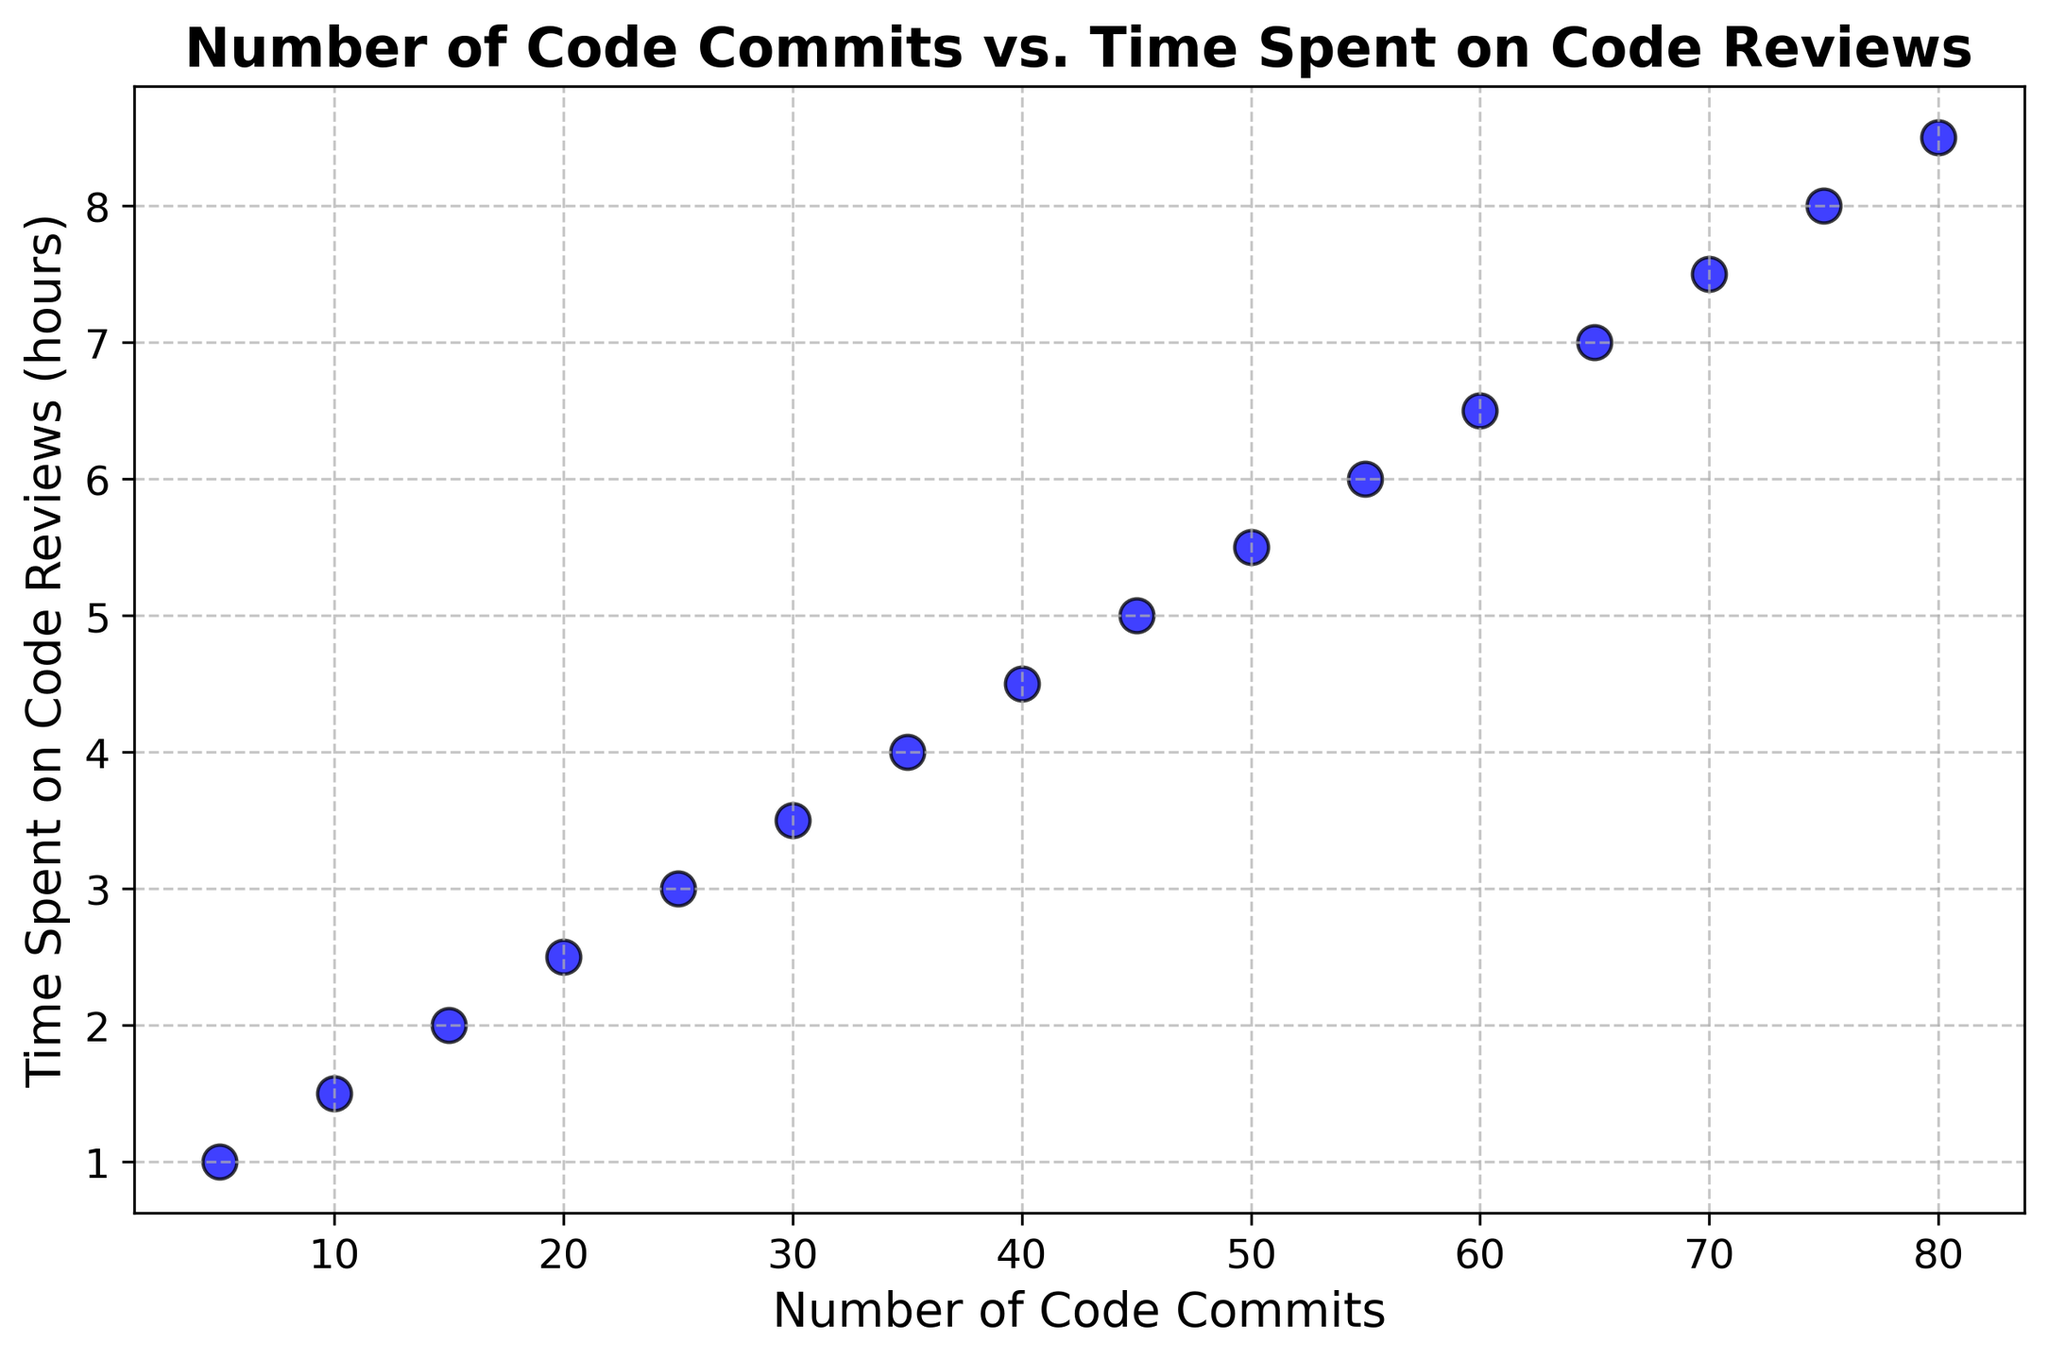Which data point shows the highest number of code commits? The scatter plot shows the number of code commits on the x-axis. The point farthest to the right represents the highest number of code commits, which is 80.
Answer: 80 Which data point shows the least amount of time spent on code reviews? The scatter plot shows the time spent on code reviews on the y-axis. The point lowest on the y-axis represents the least time spent on code reviews, which is 1 hour.
Answer: 1 hour Is there a visible trend or relationship between the number of code commits and time spent on code reviews? Observing the scatter plot, as the number of code commits increases, the time spent on code reviews also increases in a linear fashion. This indicates a positive linear relationship between the two variables.
Answer: Yes, positive linear relationship What is the time spent on code reviews when there are 45 code commits? Locate the data point for 45 code commits on the x-axis. Following it up to the corresponding point on the y-axis, we see that it corresponds to 5 hours of code reviews.
Answer: 5 hours Which has more commits: the data point with 4.5 hours of reviews or the data point with 7.5 hours of reviews? The data points for 4.5 hours and 7.5 hours of reviews fall at 40 commits and 70 commits, respectively. Therefore, 70 commits have more.
Answer: 70 commits What is the average time spent on code reviews for the data points with exactly 25 to 55 code commits? Identify the data points within the range 25 to 55 commits (25, 30, 35, 40, 45, 50, 55). The corresponding review times are 3, 3.5, 4, 4.5, 5, 5.5, 6 hours. Calculate the average: (3+3.5+4+4.5+5+5.5+6)/7 = 31.5/7 = 4.5 hours.
Answer: 4.5 hours What is the difference in time spent on code reviews between 60 commits and 20 commits? The data point for 60 commits has 6.5 hours of review time, while 20 commits have 2.5 hours. The difference is 6.5 - 2.5 = 4 hours.
Answer: 4 hours Are there more data points that are above 5 hours or below 5 hours time spent on code reviews? Count the number of data points above 5 hours (6.5, 7, 7.5, 8, 8.5) and below 5 hours (1, 1.5, 2, 2.5, 3, 3.5, 4, 4.5). There are 5 points above and 8 points below 5 hours.
Answer: Below 5 hours What percentage of the data points fall above 6 hours of code review time? There are 3 points above 6 hours (7, 7.5, 8, 8.5). Total data points are 16. So (4/16)*100 = 25%.
Answer: 25% If the number of commits were to double from 40 to 80, by how much does the time spent on code reviews increase? The time for 40 commits is 4.5 hours while for 80 commits it is 8.5 hours. The increase is 8.5 - 4.5 = 4 hours.
Answer: 4 hours 